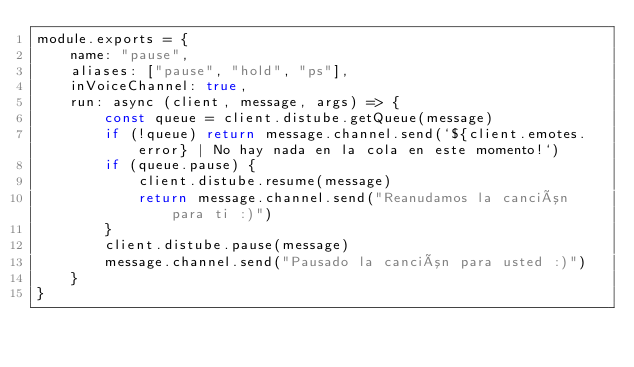Convert code to text. <code><loc_0><loc_0><loc_500><loc_500><_JavaScript_>module.exports = {
    name: "pause",
    aliases: ["pause", "hold", "ps"],
    inVoiceChannel: true,
    run: async (client, message, args) => {
        const queue = client.distube.getQueue(message)
        if (!queue) return message.channel.send(`${client.emotes.error} | No hay nada en la cola en este momento!`)
        if (queue.pause) {
            client.distube.resume(message)
            return message.channel.send("Reanudamos la canción para ti :)")
        }
        client.distube.pause(message)
        message.channel.send("Pausado la canción para usted :)")
    }
}
</code> 